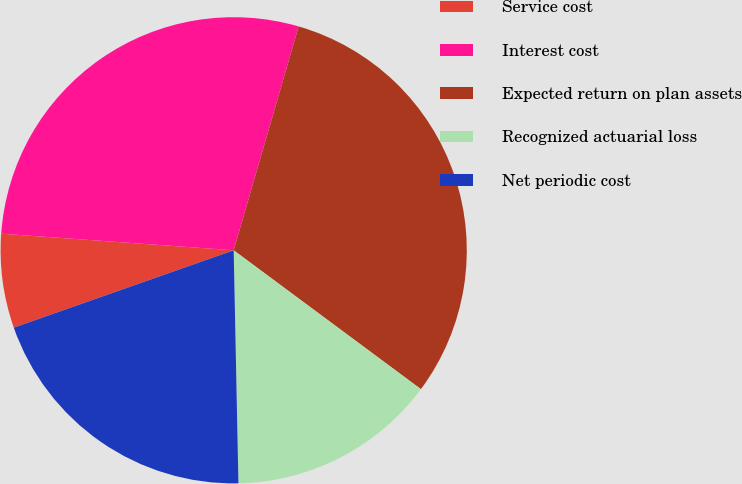Convert chart to OTSL. <chart><loc_0><loc_0><loc_500><loc_500><pie_chart><fcel>Service cost<fcel>Interest cost<fcel>Expected return on plan assets<fcel>Recognized actuarial loss<fcel>Net periodic cost<nl><fcel>6.52%<fcel>28.36%<fcel>30.66%<fcel>14.52%<fcel>19.94%<nl></chart> 